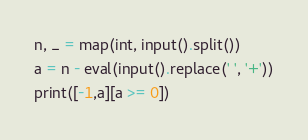<code> <loc_0><loc_0><loc_500><loc_500><_Python_>n, _ = map(int, input().split())
a = n - eval(input().replace(' ', '+'))
print([-1,a][a >= 0])</code> 